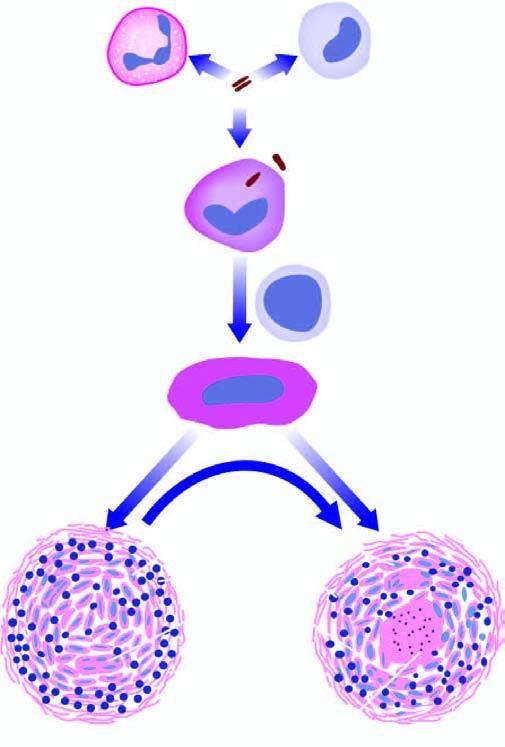what is the centre composed of?
Answer the question using a single word or phrase. Granular caseation necrosis 